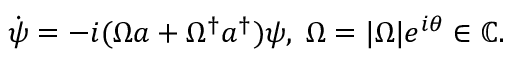<formula> <loc_0><loc_0><loc_500><loc_500>\begin{array} { r } { \dot { \psi } = - i ( \Omega a + \Omega ^ { \dagger } a ^ { \dagger } ) \psi , \, \Omega = | \Omega | e ^ { i \theta } \in \mathbb { C } . } \end{array}</formula> 